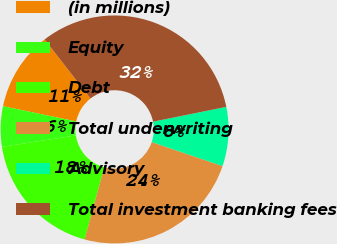Convert chart. <chart><loc_0><loc_0><loc_500><loc_500><pie_chart><fcel>(in millions)<fcel>Equity<fcel>Debt<fcel>Total underwriting<fcel>Advisory<fcel>Total investment banking fees<nl><fcel>11.21%<fcel>5.71%<fcel>18.32%<fcel>24.04%<fcel>8.38%<fcel>32.35%<nl></chart> 